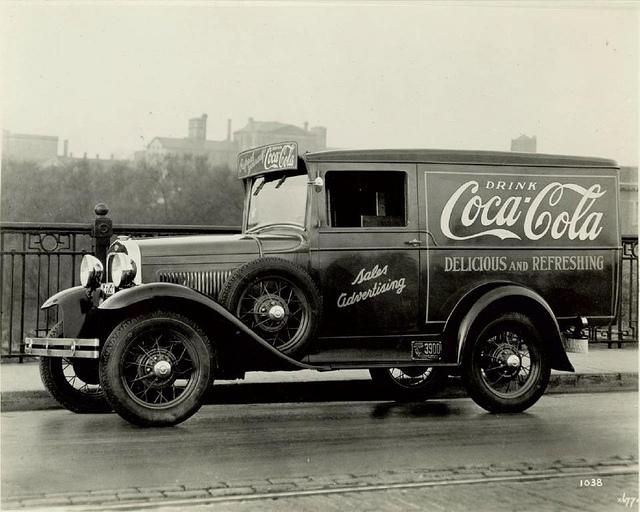Are you likely to see this truck delivering soda this week?
Concise answer only. No. What kind of vehicle is that?
Keep it brief. Truck. What does this truck deliver?
Give a very brief answer. Coca cola. 